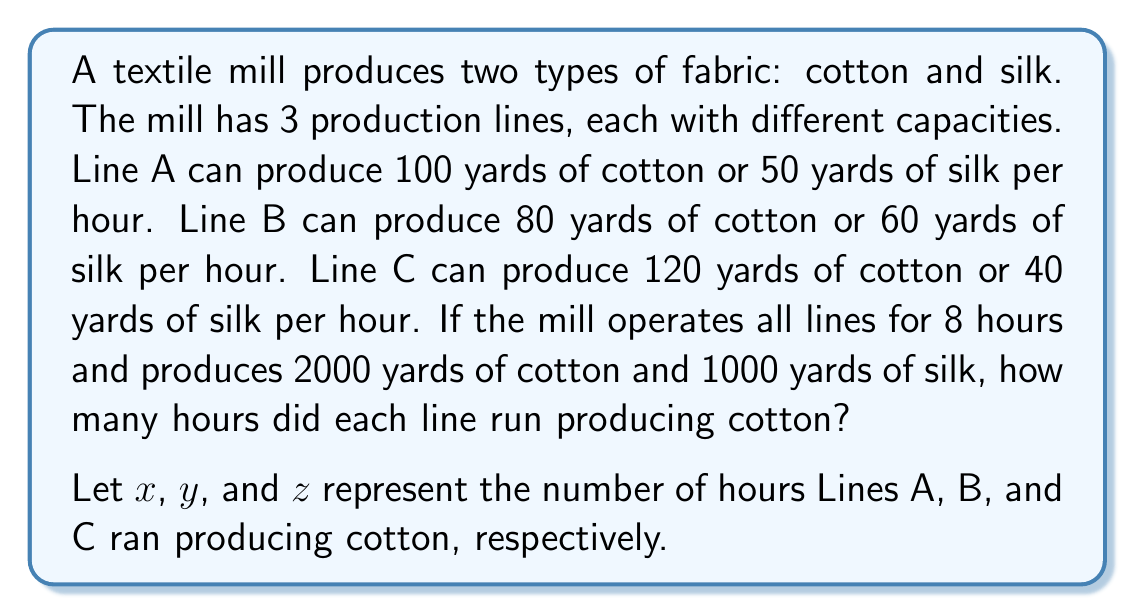Help me with this question. To solve this problem, we need to set up a system of equations based on the given information:

1. Set up the equations:
   - For cotton: $100x + 80y + 120z = 2000$
   - For silk: $50(8-x) + 60(8-y) + 40(8-z) = 1000$
   - Total time constraint: $x + y + z \leq 24$ (sum of hours should not exceed 24)

2. Simplify the silk equation:
   $400 - 50x + 480 - 60y + 320 - 40z = 1000$
   $1200 - 50x - 60y - 40z = 1000$
   $50x + 60y + 40z = 200$

3. Now we have a system of two equations:
   $$\begin{cases}
   100x + 80y + 120z = 2000 \\
   50x + 60y + 40z = 200
   \end{cases}$$

4. Multiply the second equation by 2:
   $$\begin{cases}
   100x + 80y + 120z = 2000 \\
   100x + 120y + 80z = 400
   \end{cases}$$

5. Subtract the second equation from the first:
   $-40y + 40z = 1600$
   $z - y = 40$

6. Substitute this into the first equation:
   $100x + 80y + 120(y+40) = 2000$
   $100x + 200y = 1200$
   $x + 2y = 12$

7. Now we have:
   $$\begin{cases}
   x + 2y = 12 \\
   z - y = 40
   \end{cases}$$

8. Given the time constraint, we can deduce that $z = 8$ (as it's the maximum possible value for z).

9. From $z - y = 40$, we get $y = -32$, which is not possible. So, we need to adjust our assumptions.

10. Let's try $z = 7$. Then $y = -33$, which is still not possible.

11. Let's try $z = 6$. Then $y = -34$, which is not possible.

12. Let's try $z = 5$. Then $y = -35$, which is not possible.

13. Let's try $z = 4$. Then $y = -36$, which is not possible.

14. Let's try $z = 3$. Then $y = 3$, which is possible.

15. From $x + 2y = 12$, we get $x + 2(3) = 12$, so $x = 6$.

16. Check if this solution satisfies all conditions:
    - $6 + 3 + 3 = 12 \leq 24$ (time constraint satisfied)
    - $100(6) + 80(3) + 120(3) = 1500 + 1500 = 2000$ (cotton production satisfied)
    - $50(2) + 60(5) + 40(5) = 100 + 300 + 200 = 600$ (silk production satisfied)

Therefore, Line A ran for 6 hours, Line B for 3 hours, and Line C for 3 hours producing cotton.
Answer: Line A: 6 hours, Line B: 3 hours, Line C: 3 hours 